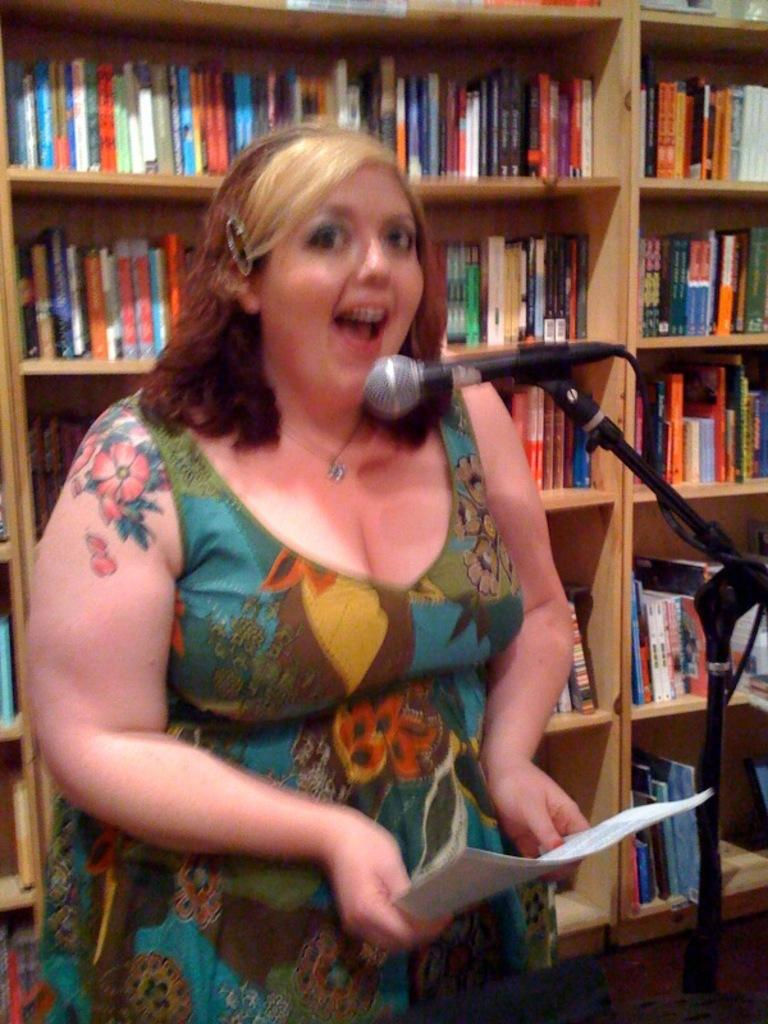What is the woman in the image doing? The woman is standing at the mic in the image. What is the woman holding in the image? The woman is holding papers in the image. What can be seen in the background of the image? There are many books arranged in shelves in the background of the image. What type of brass instrument is the woman playing in the image? There is no brass instrument present in the image; the woman is standing at the mic and holding papers. 